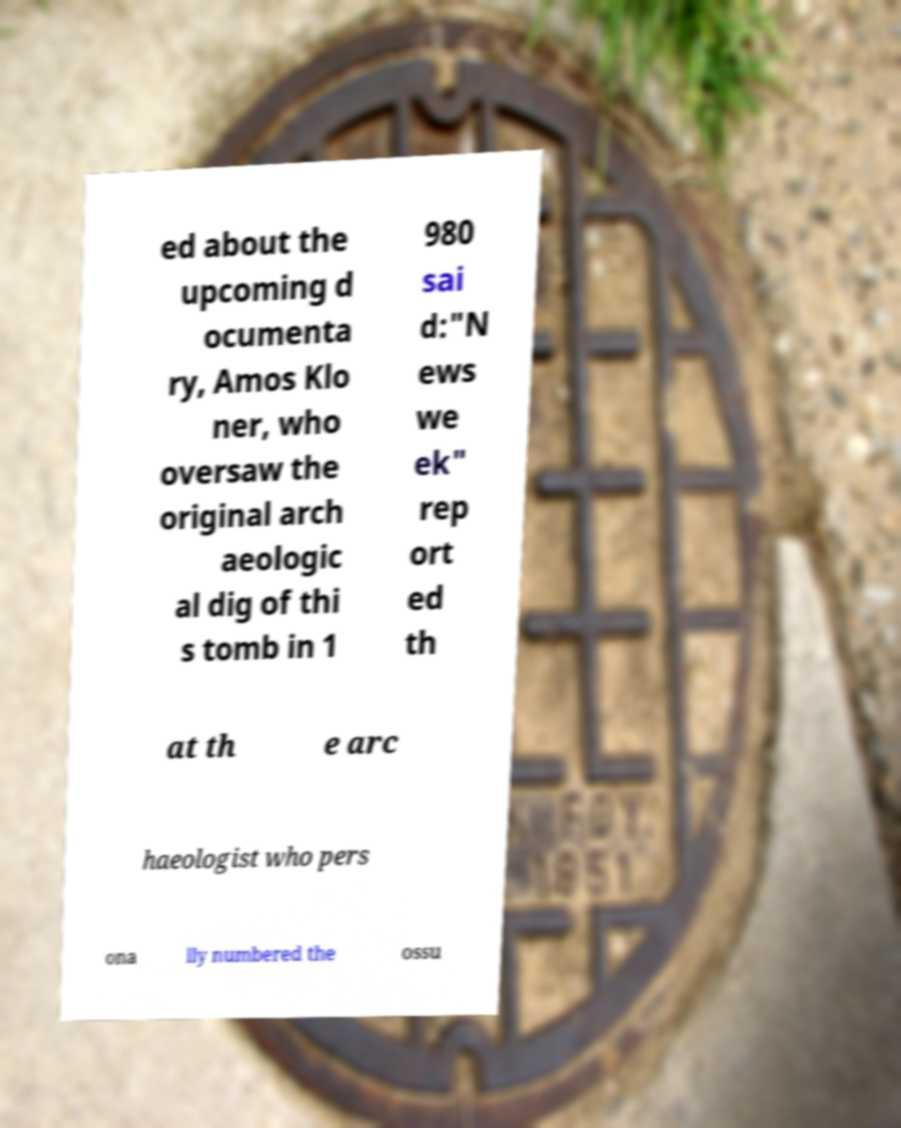Can you accurately transcribe the text from the provided image for me? ed about the upcoming d ocumenta ry, Amos Klo ner, who oversaw the original arch aeologic al dig of thi s tomb in 1 980 sai d:"N ews we ek" rep ort ed th at th e arc haeologist who pers ona lly numbered the ossu 